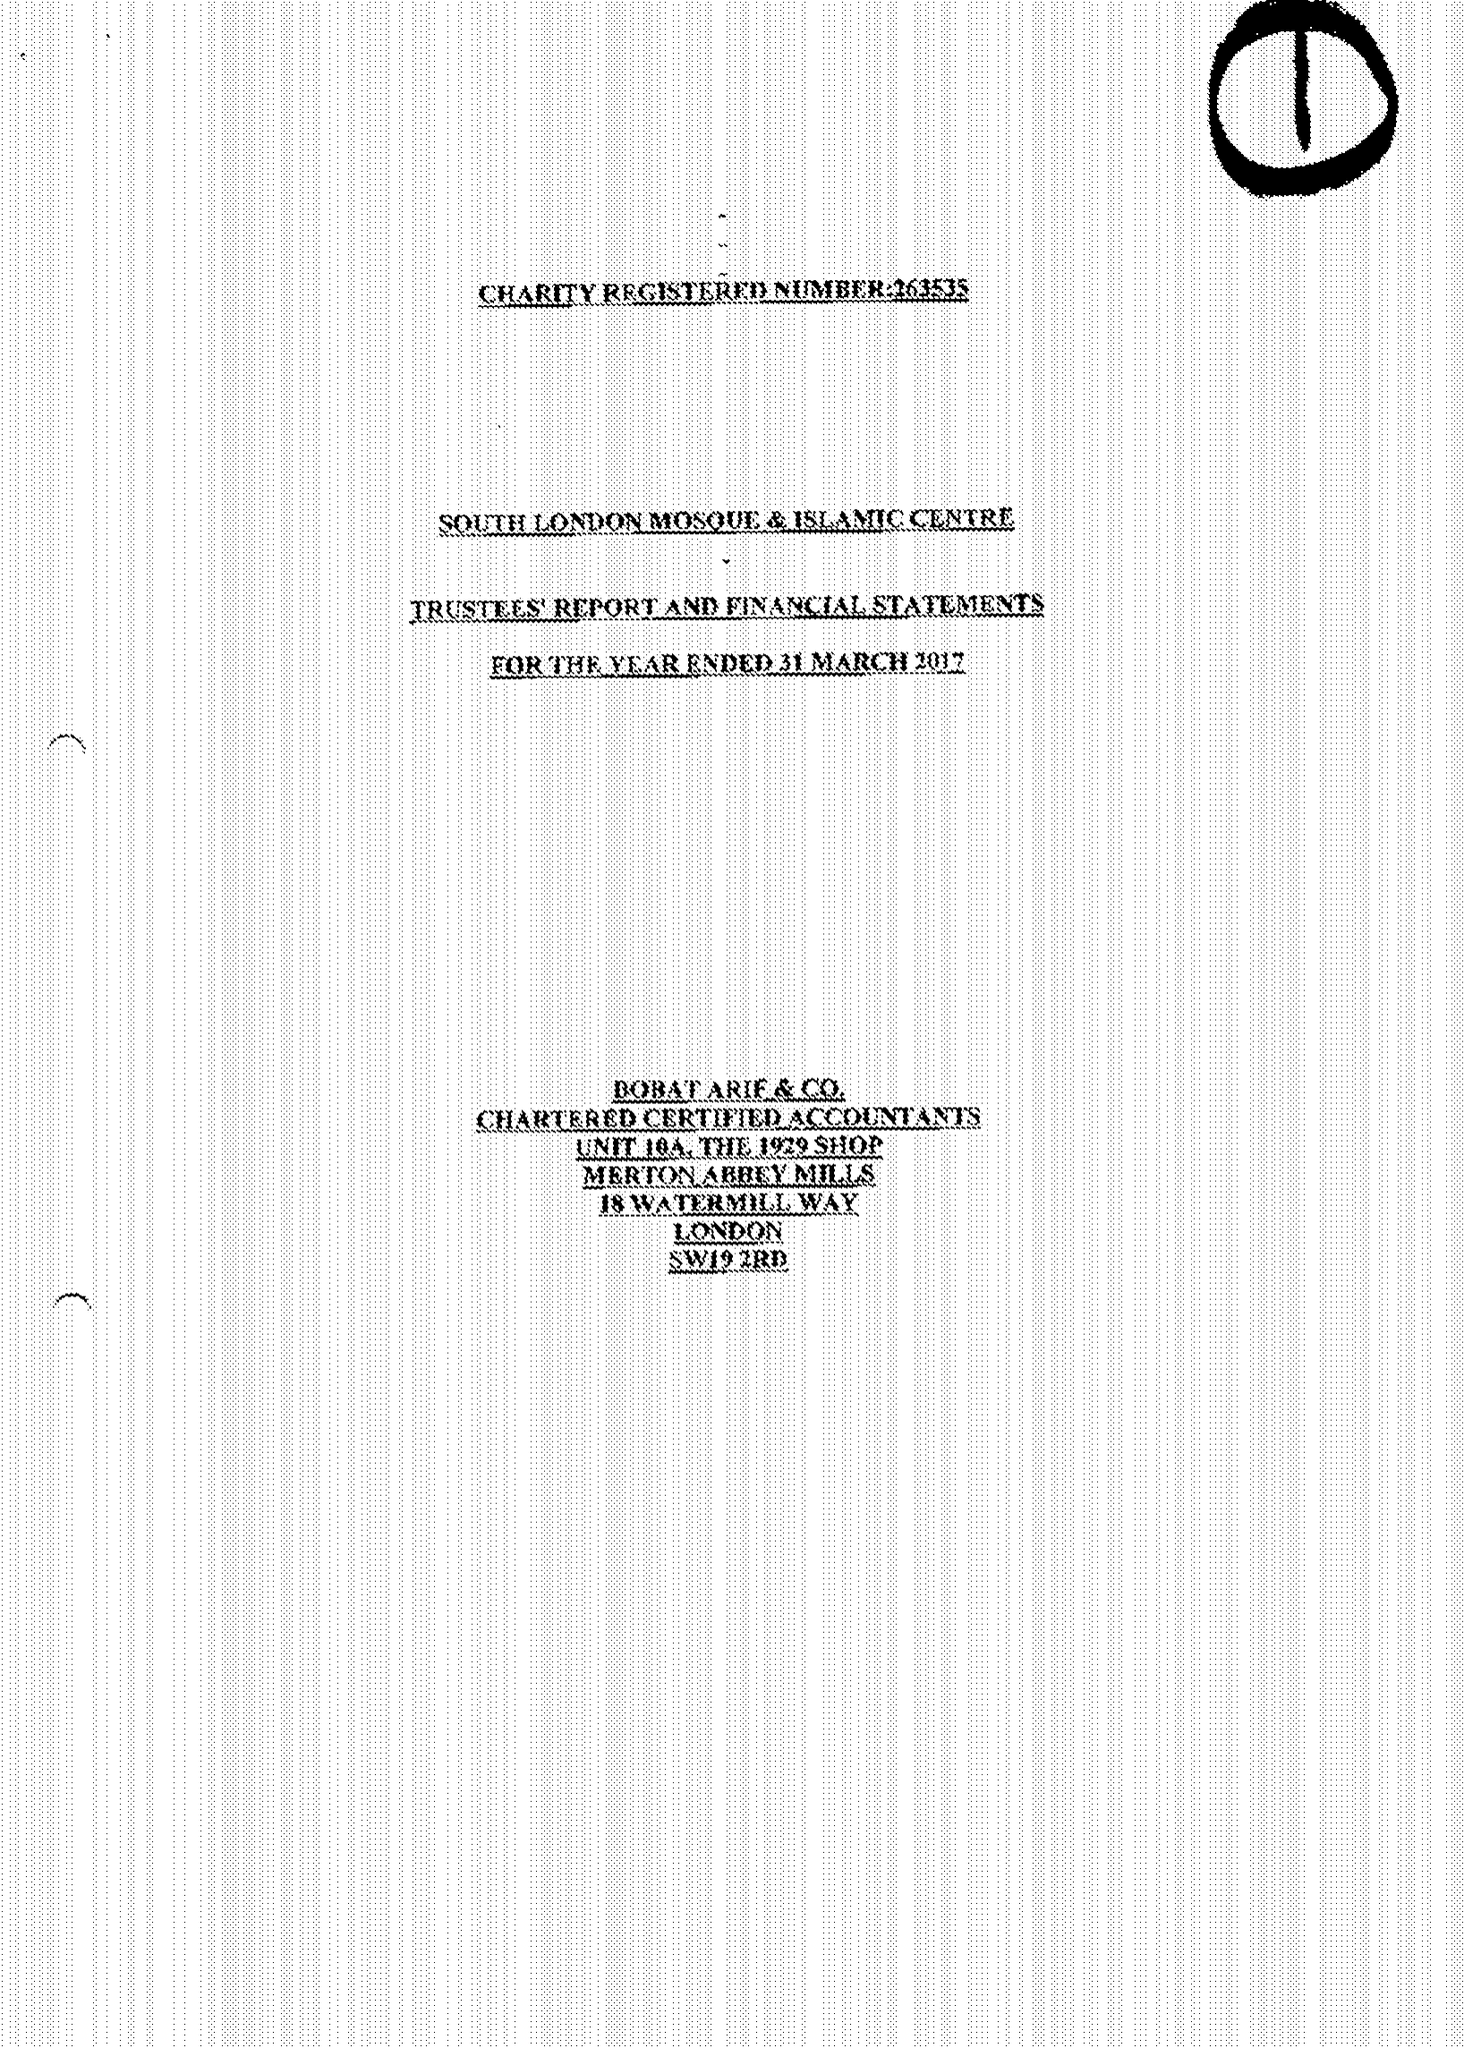What is the value for the charity_number?
Answer the question using a single word or phrase. 263535 